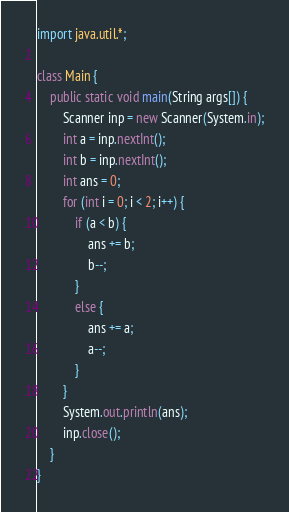<code> <loc_0><loc_0><loc_500><loc_500><_Java_>import java.util.*;

class Main {
    public static void main(String args[]) {
        Scanner inp = new Scanner(System.in);
        int a = inp.nextInt();
        int b = inp.nextInt();
        int ans = 0;
        for (int i = 0; i < 2; i++) {
            if (a < b) {
                ans += b;
                b--;
            }
            else {
                ans += a;
                a--;
            }
        }
        System.out.println(ans);
        inp.close();
    }
}
</code> 